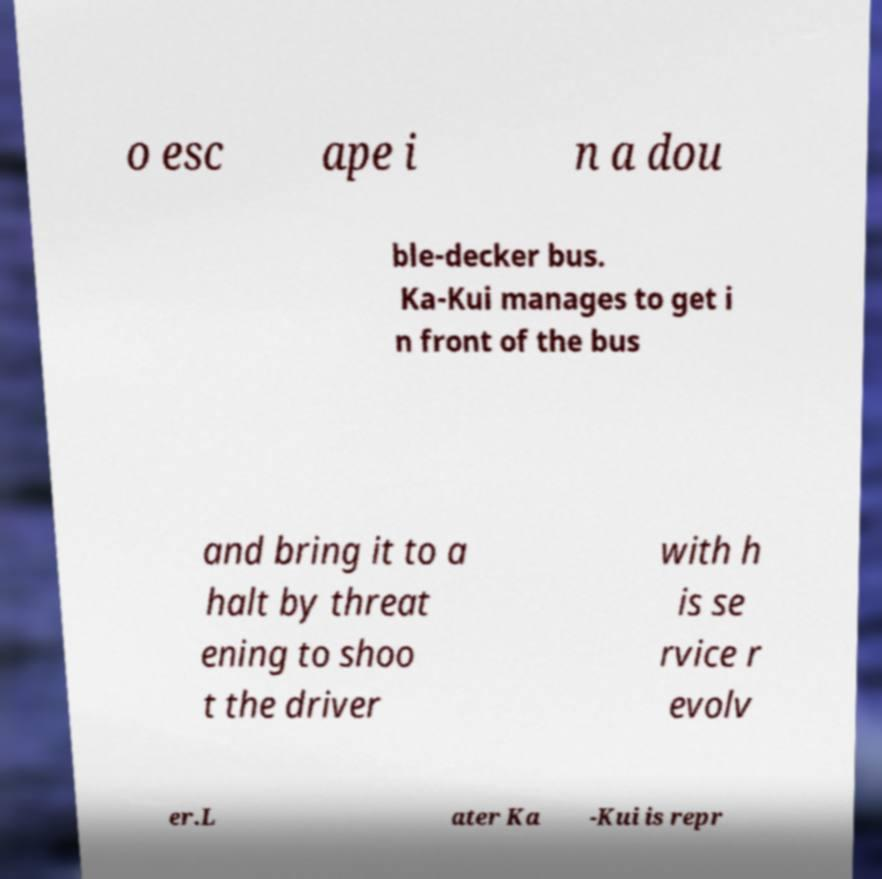What messages or text are displayed in this image? I need them in a readable, typed format. o esc ape i n a dou ble-decker bus. Ka-Kui manages to get i n front of the bus and bring it to a halt by threat ening to shoo t the driver with h is se rvice r evolv er.L ater Ka -Kui is repr 